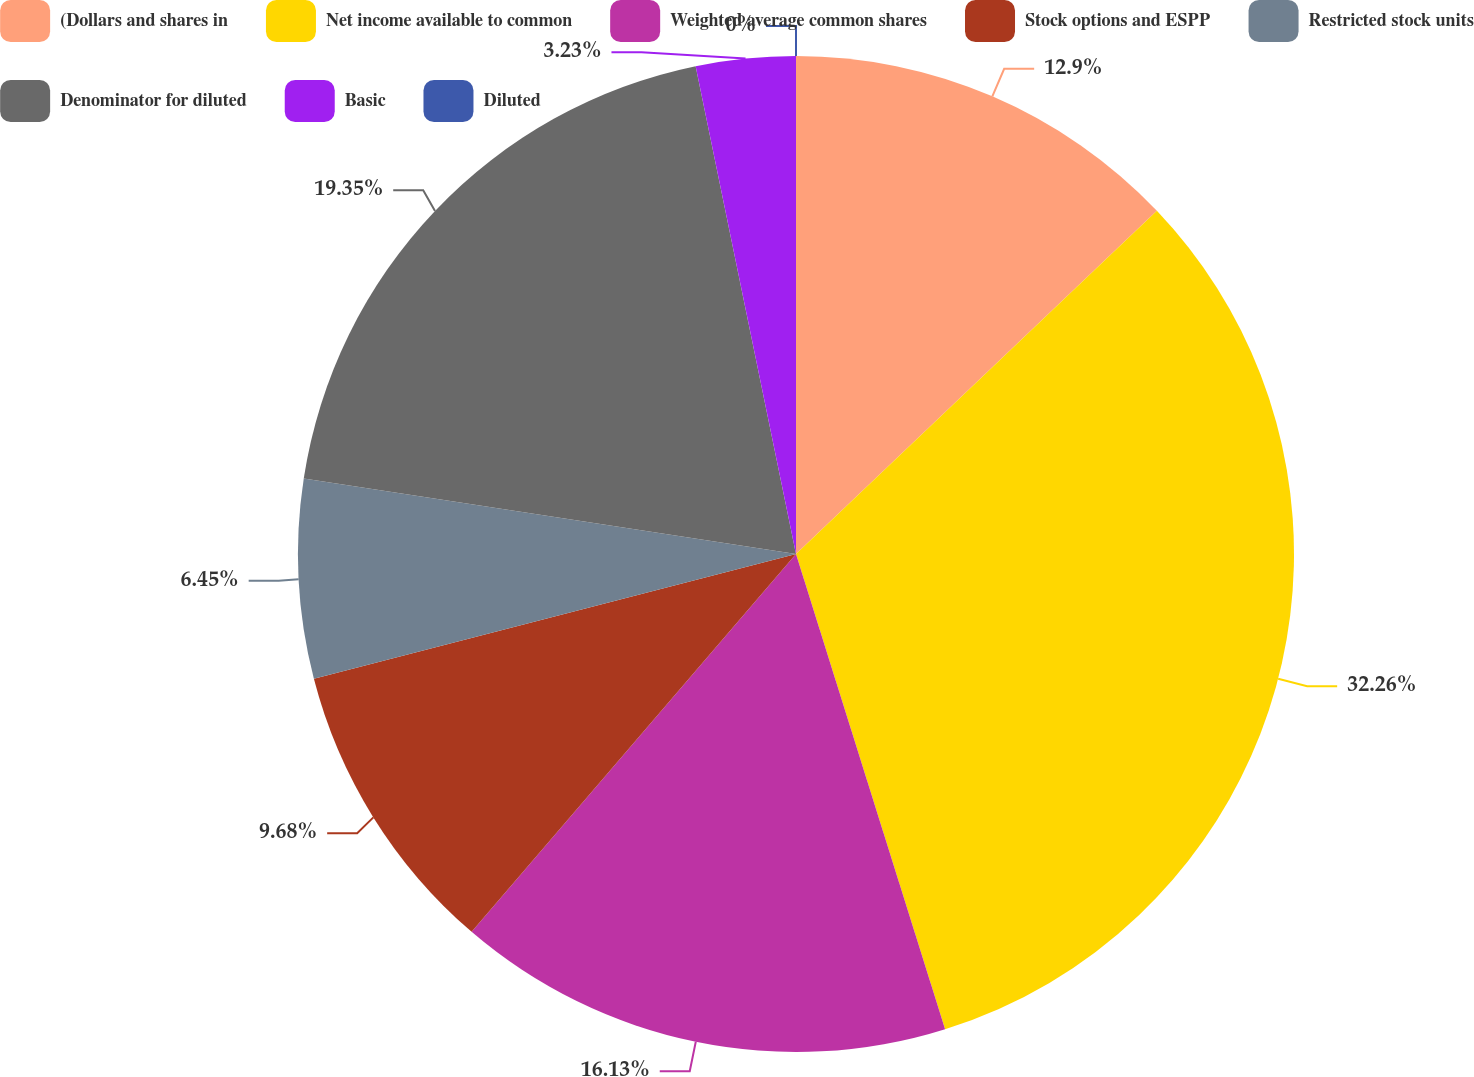<chart> <loc_0><loc_0><loc_500><loc_500><pie_chart><fcel>(Dollars and shares in<fcel>Net income available to common<fcel>Weighted average common shares<fcel>Stock options and ESPP<fcel>Restricted stock units<fcel>Denominator for diluted<fcel>Basic<fcel>Diluted<nl><fcel>12.9%<fcel>32.26%<fcel>16.13%<fcel>9.68%<fcel>6.45%<fcel>19.35%<fcel>3.23%<fcel>0.0%<nl></chart> 